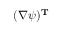<formula> <loc_0><loc_0><loc_500><loc_500>( \nabla \psi ) ^ { T }</formula> 